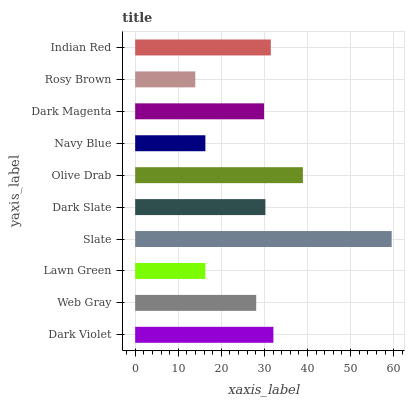Is Rosy Brown the minimum?
Answer yes or no. Yes. Is Slate the maximum?
Answer yes or no. Yes. Is Web Gray the minimum?
Answer yes or no. No. Is Web Gray the maximum?
Answer yes or no. No. Is Dark Violet greater than Web Gray?
Answer yes or no. Yes. Is Web Gray less than Dark Violet?
Answer yes or no. Yes. Is Web Gray greater than Dark Violet?
Answer yes or no. No. Is Dark Violet less than Web Gray?
Answer yes or no. No. Is Dark Slate the high median?
Answer yes or no. Yes. Is Dark Magenta the low median?
Answer yes or no. Yes. Is Web Gray the high median?
Answer yes or no. No. Is Dark Slate the low median?
Answer yes or no. No. 